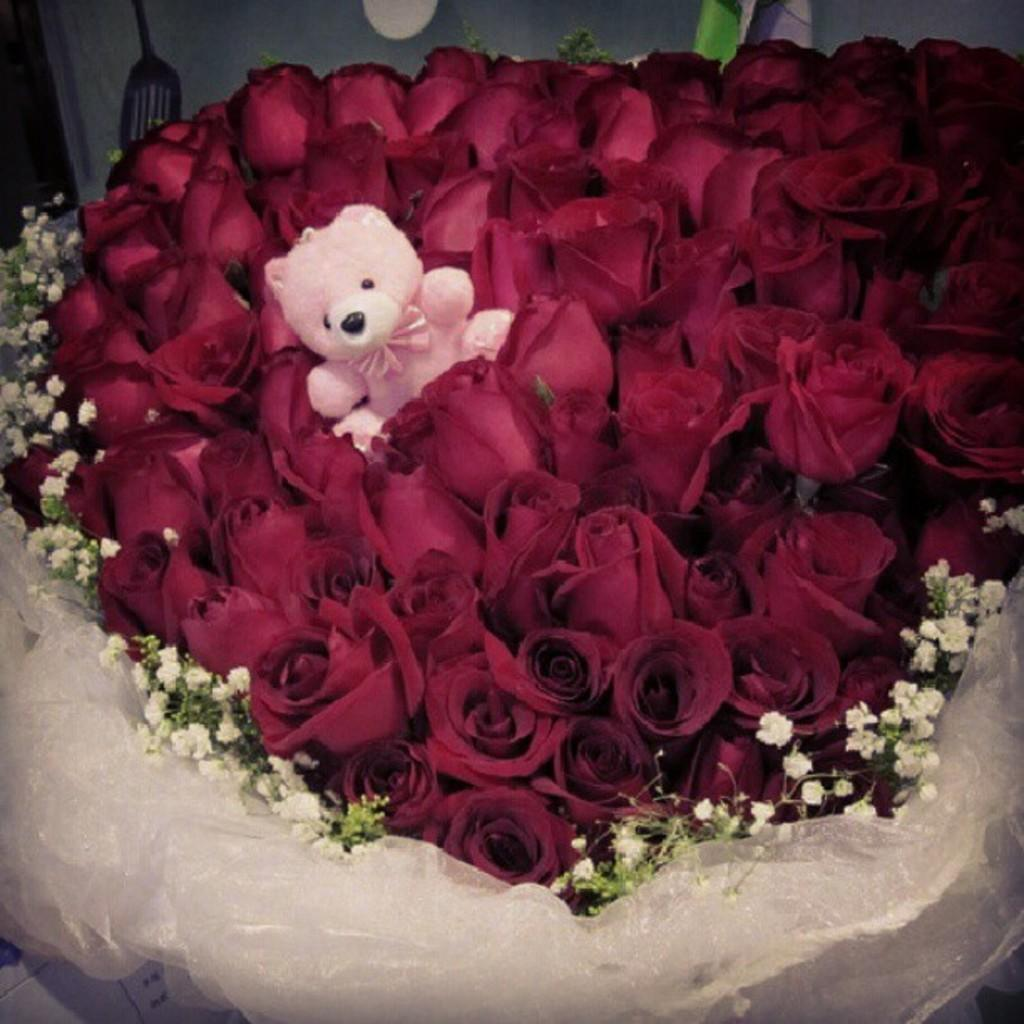What type of toy is present in the image? There is a teddy bear in the image. What kind of plants can be seen in the image? There are flowers in the image. What utensil is visible in the image? There is a spoon in the image. Can you describe any other objects in the image? There are some unspecified objects in the image. What type of steel is used to make the root in the image? There is no steel or root present in the image. How does the teddy bear smash the flowers in the image? The teddy bear does not smash the flowers in the image; they are separate objects. 